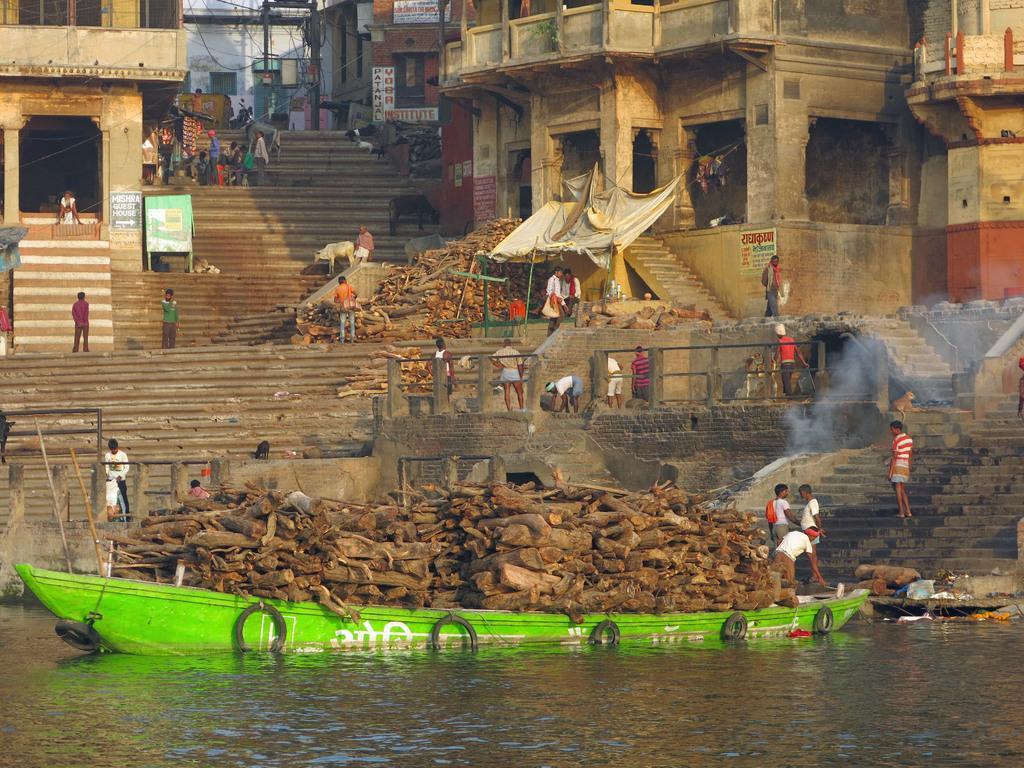Please provide a concise description of this image. This picture describes about group of people, and a green color boat in the water, and we can see wooden barks in the boat, in the background we can find few hoardings, buildings and poles. 